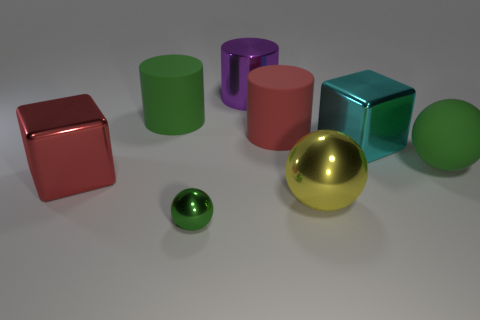What number of things are either cyan matte spheres or big metal objects in front of the big matte ball?
Your response must be concise. 2. The shiny object that is the same color as the large matte ball is what size?
Provide a succinct answer. Small. What is the shape of the large rubber object that is on the left side of the small metal ball?
Your answer should be very brief. Cylinder. Does the cube that is behind the red cube have the same color as the rubber sphere?
Give a very brief answer. No. There is a big thing that is the same color as the rubber sphere; what is its material?
Keep it short and to the point. Rubber. There is a green sphere that is on the right side of the yellow thing; is its size the same as the big red rubber object?
Make the answer very short. Yes. Are there any large cylinders that have the same color as the tiny shiny thing?
Your response must be concise. Yes. There is a large thing that is behind the big green cylinder; is there a green sphere that is right of it?
Ensure brevity in your answer.  Yes. Is there a large red cube made of the same material as the small sphere?
Your answer should be compact. Yes. What is the material of the green object that is behind the ball that is behind the big yellow metal thing?
Keep it short and to the point. Rubber. 